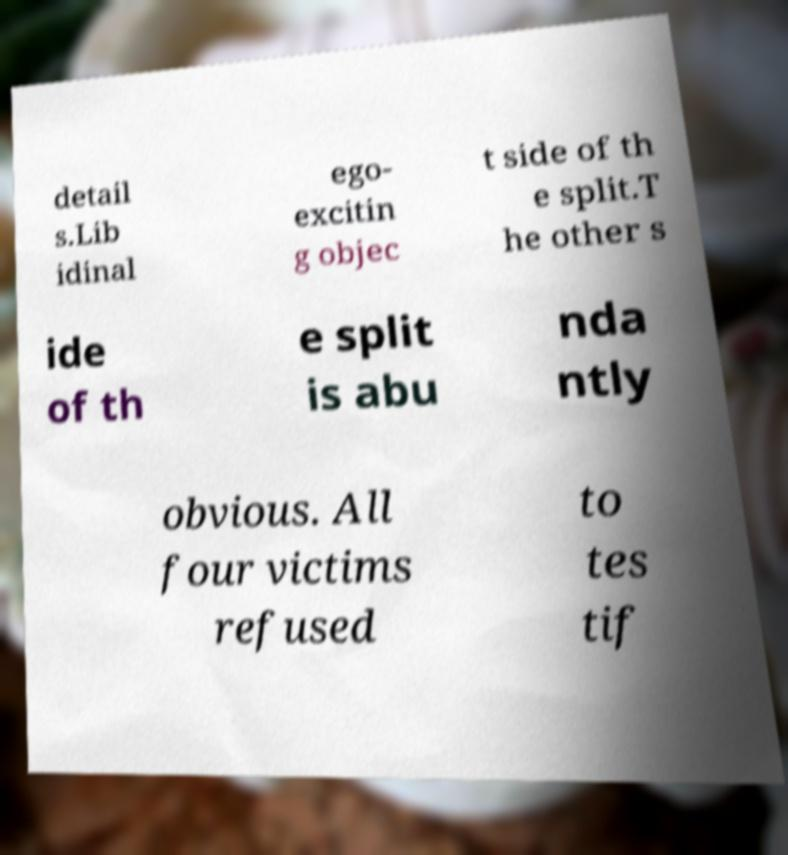What messages or text are displayed in this image? I need them in a readable, typed format. detail s.Lib idinal ego- excitin g objec t side of th e split.T he other s ide of th e split is abu nda ntly obvious. All four victims refused to tes tif 